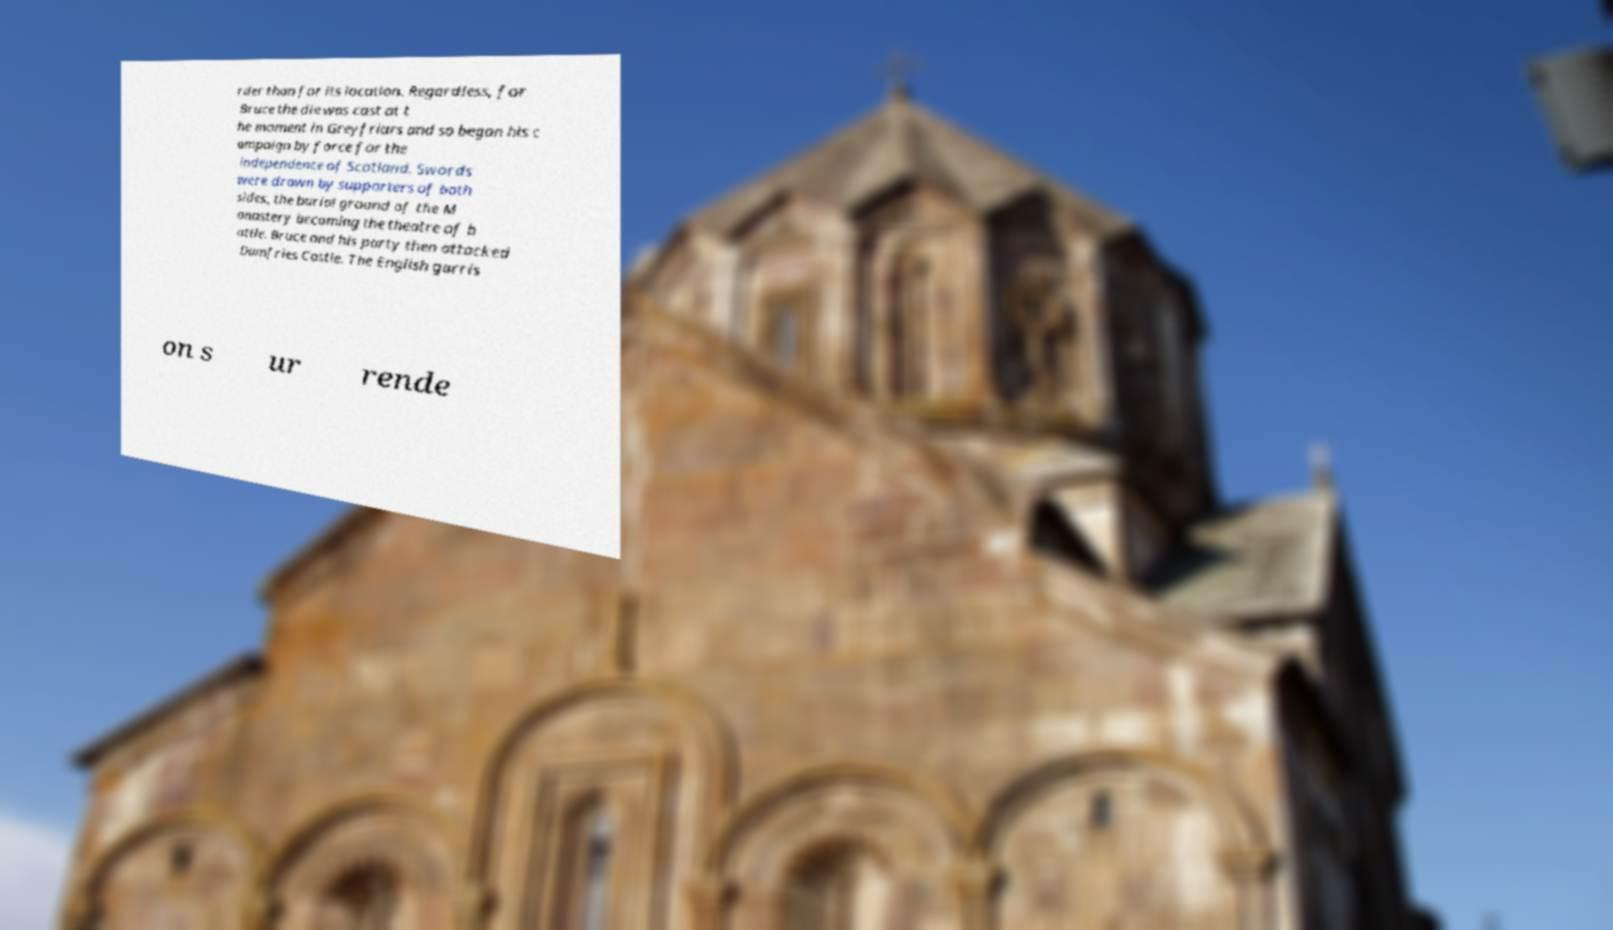Please read and relay the text visible in this image. What does it say? rder than for its location. Regardless, for Bruce the die was cast at t he moment in Greyfriars and so began his c ampaign by force for the independence of Scotland. Swords were drawn by supporters of both sides, the burial ground of the M onastery becoming the theatre of b attle. Bruce and his party then attacked Dumfries Castle. The English garris on s ur rende 